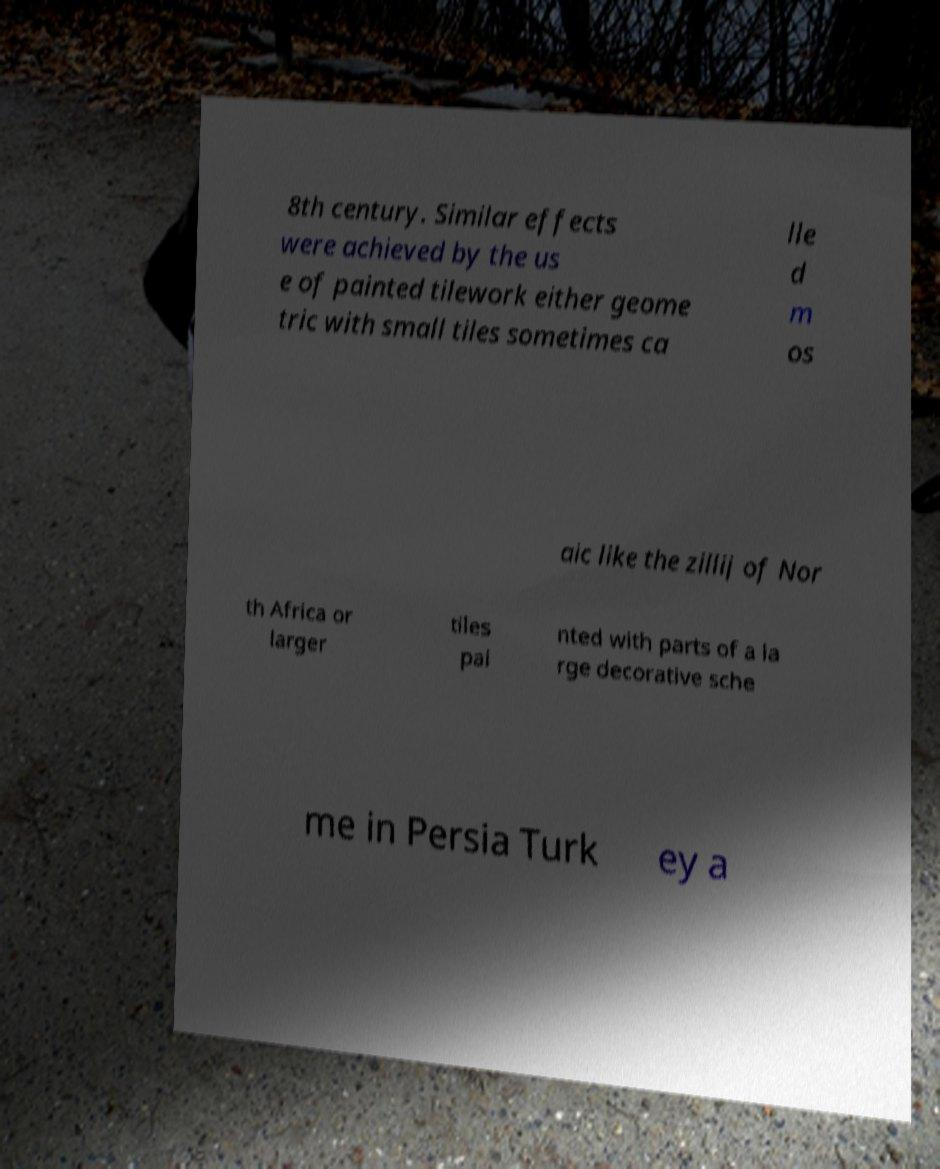Could you extract and type out the text from this image? 8th century. Similar effects were achieved by the us e of painted tilework either geome tric with small tiles sometimes ca lle d m os aic like the zillij of Nor th Africa or larger tiles pai nted with parts of a la rge decorative sche me in Persia Turk ey a 